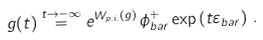<formula> <loc_0><loc_0><loc_500><loc_500>g ( t ) \overset { t \rightarrow - \infty } { = } e ^ { W _ { p . i . } ( g ) } \, \phi _ { b a r } ^ { + } \exp \left ( t \varepsilon _ { b a r } \right ) \, .</formula> 